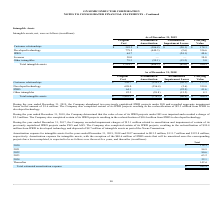According to On Semiconductor's financial document, What is resulted in completion of certain of its IPRD projects during the year ended December 31, 2019? resulting in the reclassification of $23.2 million from IPRD to developed technology.. The document states: "ompany also completed certain of its IPRD projects resulting in the reclassification of $23.2 million from IPRD to developed technology...." Also, What was the impact of abandoning two previously capitalized IPRD projects under ISG during the year ended December 31, 2019? ecorded aggregate impairment losses in the amount of $1.6 million.. The document states: "eviously capitalized IPRD projects under ISG and recorded aggregate impairment losses in the amount of $1.6 million. The Company also completed certai..." Also, What is resulted in completion of certain of its IPRD projects during the year ended December 31, 2019? resulting in the reclassification of $10.4 million from IPRD to developed technology.. The document states: "ompany also completed certain of its IPRD projects resulting in the reclassification of $10.4 million from IPRD to developed technology...." Also, can you calculate: What is the increase/ (decrease) in Original Cost of Customer relationships from December 31, 2018 to 2019? Based on the calculation: 585.2-556.7, the result is 28.5 (in millions). This is based on the information: "Customer relationships $ 556.7 $ (359.1) $ (20.1) $ 177.5 Customer relationships $ 585.2 $ (386.8) $ (20.1) $ 178.3..." The key data points involved are: 556.7, 585.2. Also, can you calculate: What is the increase/ (decrease) in Original Cost of Developed technology from year ended December 31, 2018 to 2019? Based on the calculation: 779.5-698.0, the result is 81.5 (in millions). This is based on the information: "Developed technology 779.5 (440.3) (2.6) 336.6 Developed technology 698.0 (356.4) (2.6) 339.0..." The key data points involved are: 698.0, 779.5. Also, can you calculate: What is the average Original Cost of Customer relationships for December 31, 2018 to 2019? To answer this question, I need to perform calculations using the financial data. The calculation is: (585.2+556.7) / 2, which equals 570.95 (in millions). This is based on the information: "Customer relationships $ 556.7 $ (359.1) $ (20.1) $ 177.5 Customer relationships $ 585.2 $ (386.8) $ (20.1) $ 178.3..." The key data points involved are: 556.7, 585.2. 